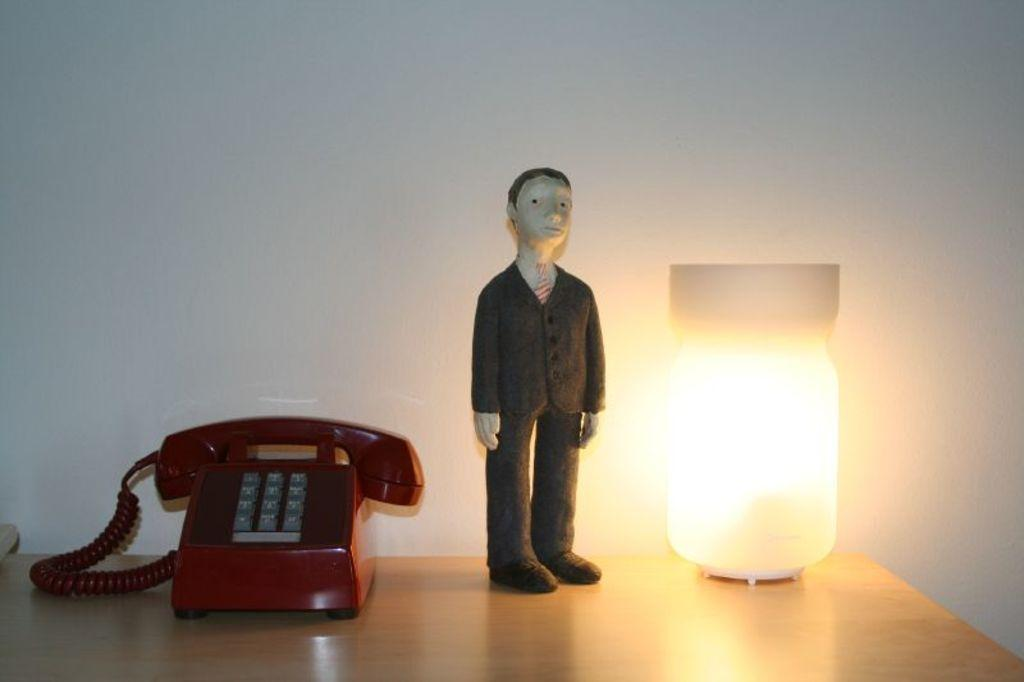What type of communication device is present in the image? There is a telephone in the image. What other object can be seen in the image? There is a toy in the image. What is used for illumination in the image? There is a lamp in the image. On what surface are these objects placed? These objects are on a wooden surface. What is visible behind the telephone? There is a wall behind the telephone. What type of button is being pressed by the rose in the image? There is no button or rose present in the image. How does the drain affect the wooden surface in the image? There is no drain present in the image, so it cannot affect the wooden surface. 